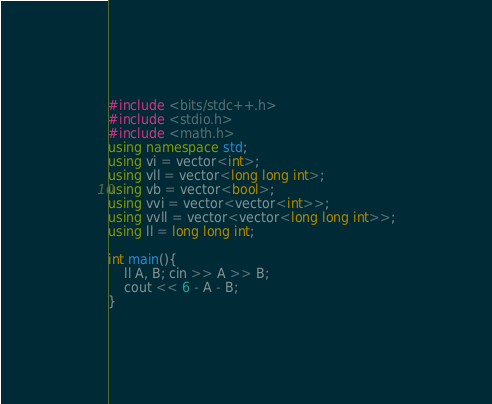<code> <loc_0><loc_0><loc_500><loc_500><_C++_>#include <bits/stdc++.h>
#include <stdio.h>
#include <math.h>
using namespace std;
using vi = vector<int>;
using vll = vector<long long int>;
using vb = vector<bool>;
using vvi = vector<vector<int>>;
using vvll = vector<vector<long long int>>;
using ll = long long int;

int main(){
    ll A, B; cin >> A >> B;
    cout << 6 - A - B;
}</code> 